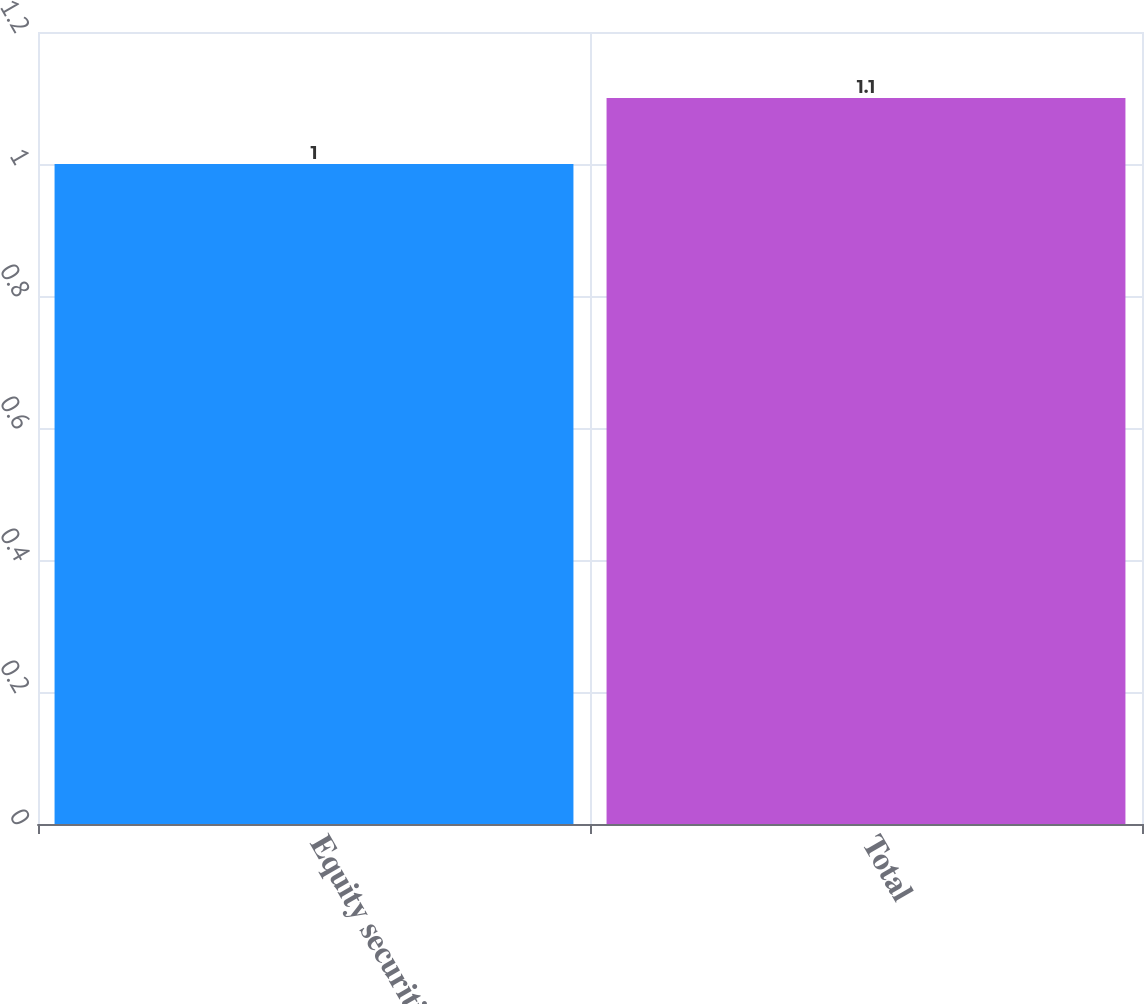Convert chart to OTSL. <chart><loc_0><loc_0><loc_500><loc_500><bar_chart><fcel>Equity securities<fcel>Total<nl><fcel>1<fcel>1.1<nl></chart> 